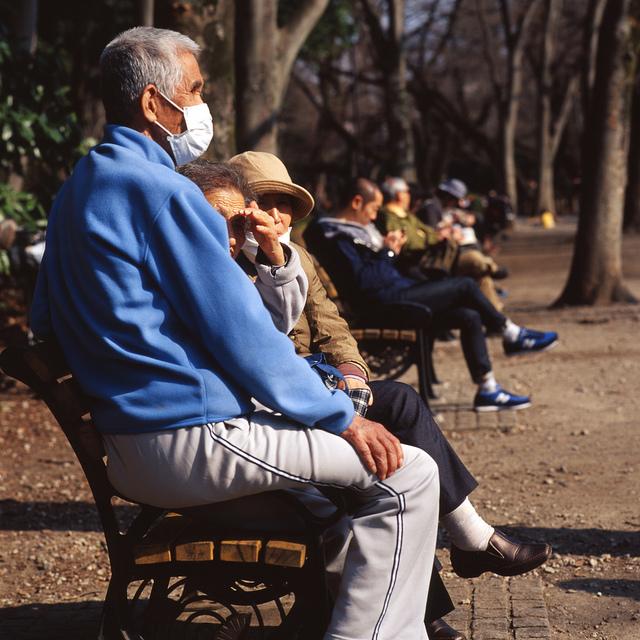Why is he wearing a mask?
Be succinct. Sick. Is it daytime?
Write a very short answer. Yes. What color is the man's sweater?
Write a very short answer. Blue. What is the woman sitting on?
Write a very short answer. Bench. 